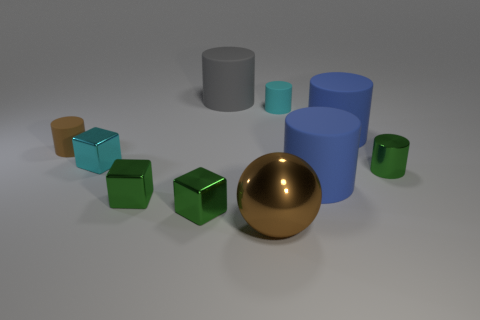Subtract all blue cylinders. How many were subtracted if there are1blue cylinders left? 1 Subtract all purple cylinders. How many green blocks are left? 2 Subtract all green cubes. How many cubes are left? 1 Subtract 3 cylinders. How many cylinders are left? 3 Subtract all green cylinders. How many cylinders are left? 5 Subtract all green cylinders. Subtract all gray balls. How many cylinders are left? 5 Subtract all cylinders. How many objects are left? 4 Subtract all big blue things. Subtract all large cylinders. How many objects are left? 5 Add 9 brown metallic balls. How many brown metallic balls are left? 10 Add 6 tiny green cylinders. How many tiny green cylinders exist? 7 